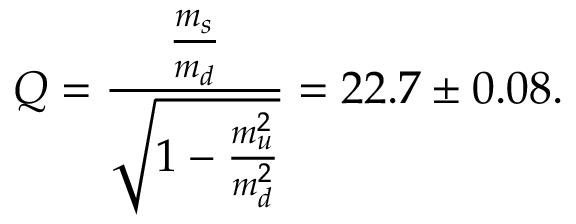Convert formula to latex. <formula><loc_0><loc_0><loc_500><loc_500>Q = { \frac { \frac { m _ { s } } { m _ { d } } } { \sqrt { 1 - { \frac { m _ { u } ^ { 2 } } { m _ { d } ^ { 2 } } } } } } = 2 2 . 7 \pm 0 . 0 8 .</formula> 